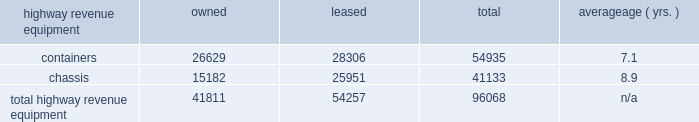Average age ( yrs. ) highway revenue equipment owned leased total .
Capital expenditures our rail network requires significant annual capital investments for replacement , improvement , and expansion .
These investments enhance safety , support the transportation needs of our customers , and improve our operational efficiency .
Additionally , we add new locomotives and freight cars to our fleet to replace older , less efficient equipment , to support growth and customer demand , and to reduce our impact on the environment through the acquisition of more fuel-efficient and low-emission locomotives .
2014 capital program 2013 during 2014 , our capital program totaled $ 4.1 billion .
( see the cash capital expenditures table in management 2019s discussion and analysis of financial condition and results of operations 2013 liquidity and capital resources 2013 financial condition , item 7. ) 2015 capital plan 2013 in 2015 , we expect our capital plan to be approximately $ 4.3 billion , which will include expenditures for ptc of approximately $ 450 million and may include non-cash investments .
We may revise our 2015 capital plan if business conditions warrant or if new laws or regulations affect our ability to generate sufficient returns on these investments .
( see discussion of our 2015 capital plan in management 2019s discussion and analysis of financial condition and results of operations 2013 2015 outlook , item 7. ) equipment encumbrances 2013 equipment with a carrying value of approximately $ 2.8 billion and $ 2.9 billion at december 31 , 2014 , and 2013 , respectively served as collateral for capital leases and other types of equipment obligations in accordance with the secured financing arrangements utilized to acquire or refinance such railroad equipment .
As a result of the merger of missouri pacific railroad company ( mprr ) with and into uprr on january 1 , 1997 , and pursuant to the underlying indentures for the mprr mortgage bonds , uprr must maintain the same value of assets after the merger in order to comply with the security requirements of the mortgage bonds .
As of the merger date , the value of the mprr assets that secured the mortgage bonds was approximately $ 6.0 billion .
In accordance with the terms of the indentures , this collateral value must be maintained during the entire term of the mortgage bonds irrespective of the outstanding balance of such bonds .
Environmental matters 2013 certain of our properties are subject to federal , state , and local laws and regulations governing the protection of the environment .
( see discussion of environmental issues in business 2013 governmental and environmental regulation , item 1 , and management 2019s discussion and analysis of financial condition and results of operations 2013 critical accounting policies 2013 environmental , item 7. ) item 3 .
Legal proceedings from time to time , we are involved in legal proceedings , claims , and litigation that occur in connection with our business .
We routinely assess our liabilities and contingencies in connection with these matters based upon the latest available information and , when necessary , we seek input from our third-party advisors when making these assessments .
Consistent with sec rules and requirements , we describe below material pending legal proceedings ( other than ordinary routine litigation incidental to our business ) , material proceedings known to be contemplated by governmental authorities , other proceedings arising under federal , state , or local environmental laws and regulations ( including governmental proceedings involving potential fines , penalties , or other monetary sanctions in excess of $ 100000 ) , and such other pending matters that we may determine to be appropriate. .
How much of the 2015 capital plan is for ptc expenditures? 
Computations: (450 / (4.3 * 1000))
Answer: 0.10465. 